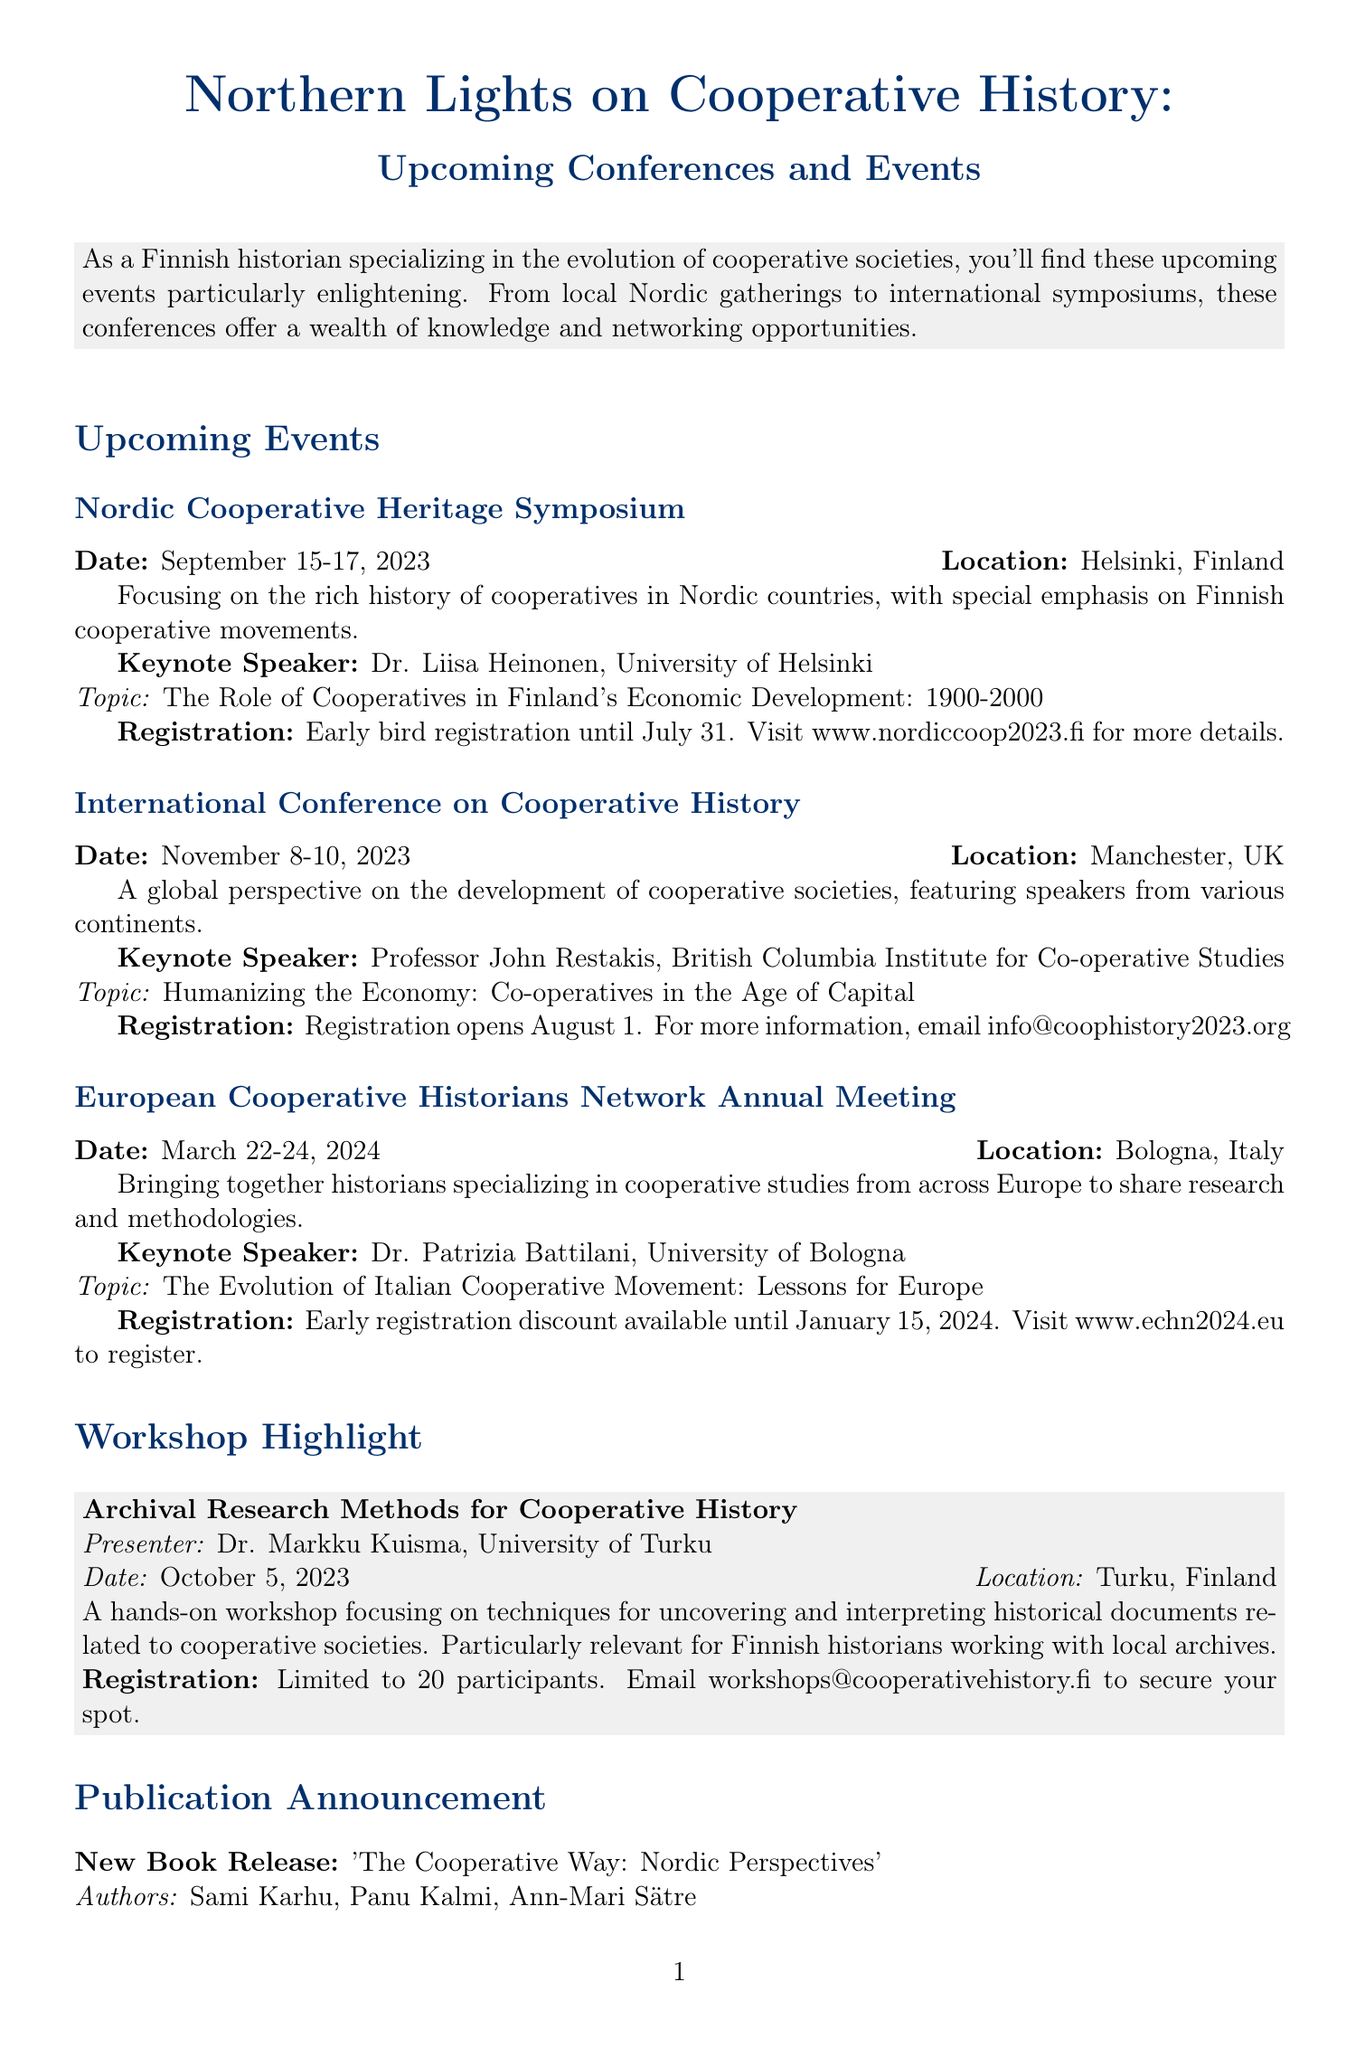What is the date of the Nordic Cooperative Heritage Symposium? The date is specified in the document as September 15-17, 2023.
Answer: September 15-17, 2023 Who is the keynote speaker for the International Conference on Cooperative History? The document mentions Professor John Restakis as the keynote speaker for this event.
Answer: Professor John Restakis What is the registration deadline for early bird registration for the Nordic Cooperative Heritage Symposium? The document states that early bird registration ends on July 31.
Answer: July 31 Where will the European Cooperative Historians Network Annual Meeting be held? The document specifies that this meeting will take place in Bologna, Italy.
Answer: Bologna, Italy What is the main topic of Dr. Liisa Heinonen's keynote speech? The topic is indicated in the document as "The Role of Cooperatives in Finland's Economic Development: 1900-2000."
Answer: The Role of Cooperatives in Finland's Economic Development: 1900-2000 What workshop is highlighted in the newsletter? The document highlights the workshop titled "Archival Research Methods for Cooperative History."
Answer: Archival Research Methods for Cooperative History When is the next meeting of the Finnish Cooperative Historians' Coffee Hour? The document mentions that the next meeting is on August 2, 2023.
Answer: August 2, 2023 Who are the authors of the newly released book titled 'The Cooperative Way: Nordic Perspectives'? The document lists Sami Karhu, Panu Kalmi, and Ann-Mari Sätre as the authors.
Answer: Sami Karhu, Panu Kalmi, Ann-Mari Sätre What is the maximum number of participants for the workshop on archival research? The document states that the workshop is limited to 20 participants.
Answer: 20 participants 